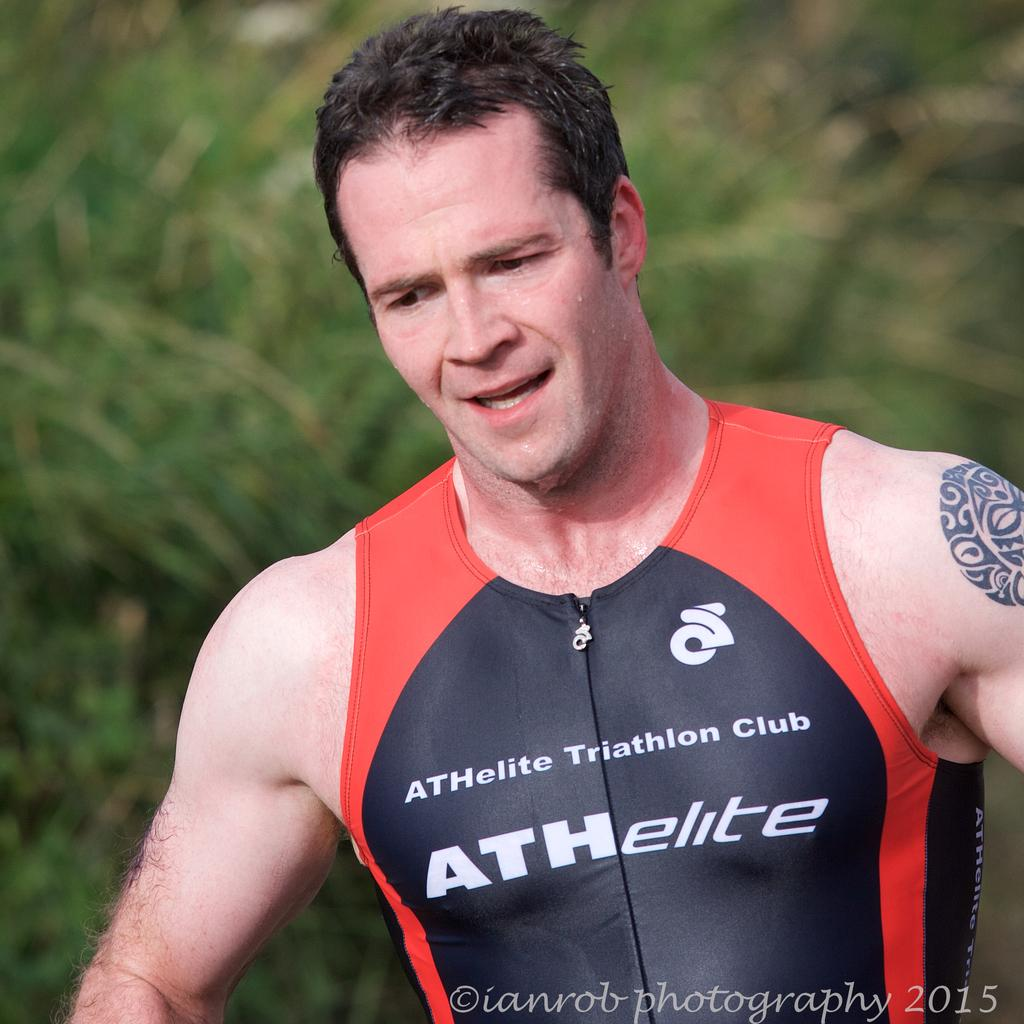Provide a one-sentence caption for the provided image. A man wearing a sleeveless shirt with ATHelite Triathlon Club on it. 